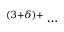<formula> <loc_0><loc_0><loc_500><loc_500>^ { ( 3 + \delta ) + } \dots</formula> 